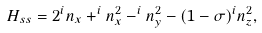Convert formula to latex. <formula><loc_0><loc_0><loc_500><loc_500>H _ { s s } = 2 ^ { i } n _ { x } + ^ { i } n ^ { 2 } _ { x } - ^ { i } n ^ { 2 } _ { y } - ( 1 - \sigma ) ^ { i } n ^ { 2 } _ { z } ,</formula> 